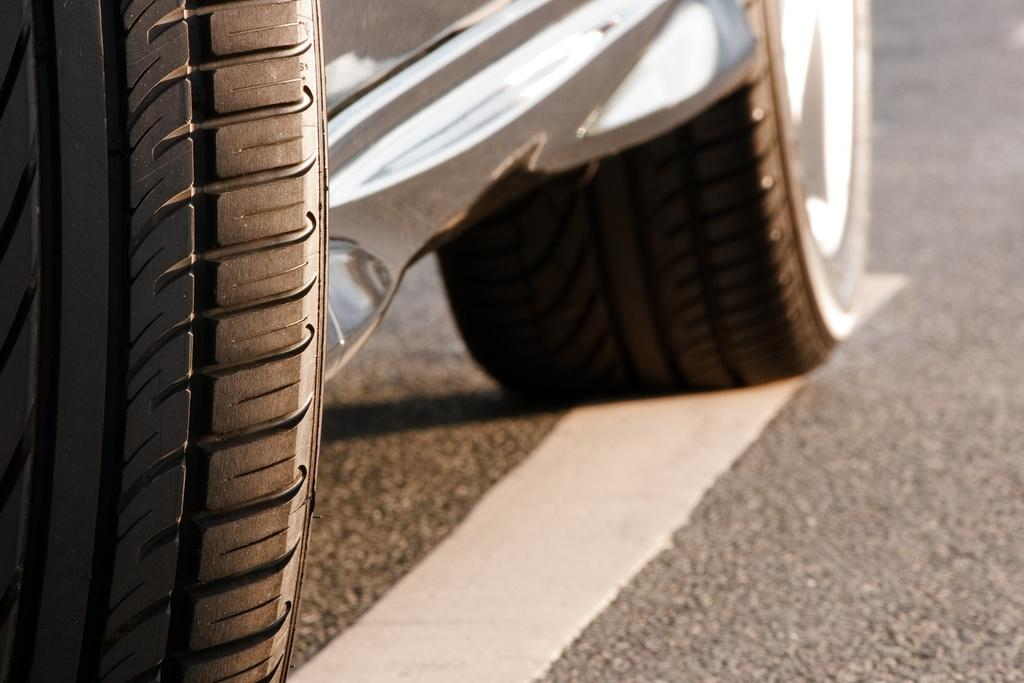What is the main subject of the image? There is a car in the image. Where is the car located in the image? The car is at the bottom of the image. What can be seen on the right side of the image? There is a road on the right side of the image. How would you describe the background of the image? The background of the image is blurred. How many waves can be seen in the image? There are no waves present in the image. What type of bed is visible in the image? There is no bed present in the image. 